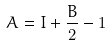<formula> <loc_0><loc_0><loc_500><loc_500>A = I + \frac { B } { 2 } - 1</formula> 